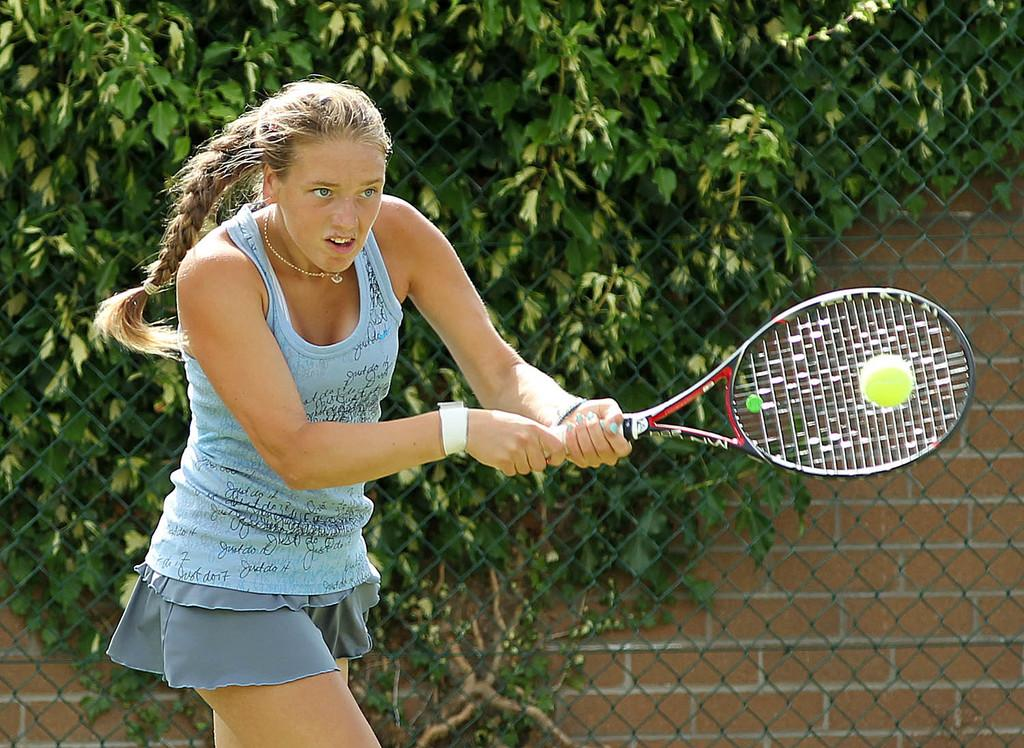Who is the main subject in the image? There is a woman in the image. What is the woman holding in the image? The woman is holding a tennis bat. What activity is the woman engaged in? The woman is playing with a ball. What can be seen in the background of the image? There is a wall and trees in the background of the image. How does the crowd react to the woman's performance in the image? There is no crowd present in the image, so it is not possible to determine their reaction. 